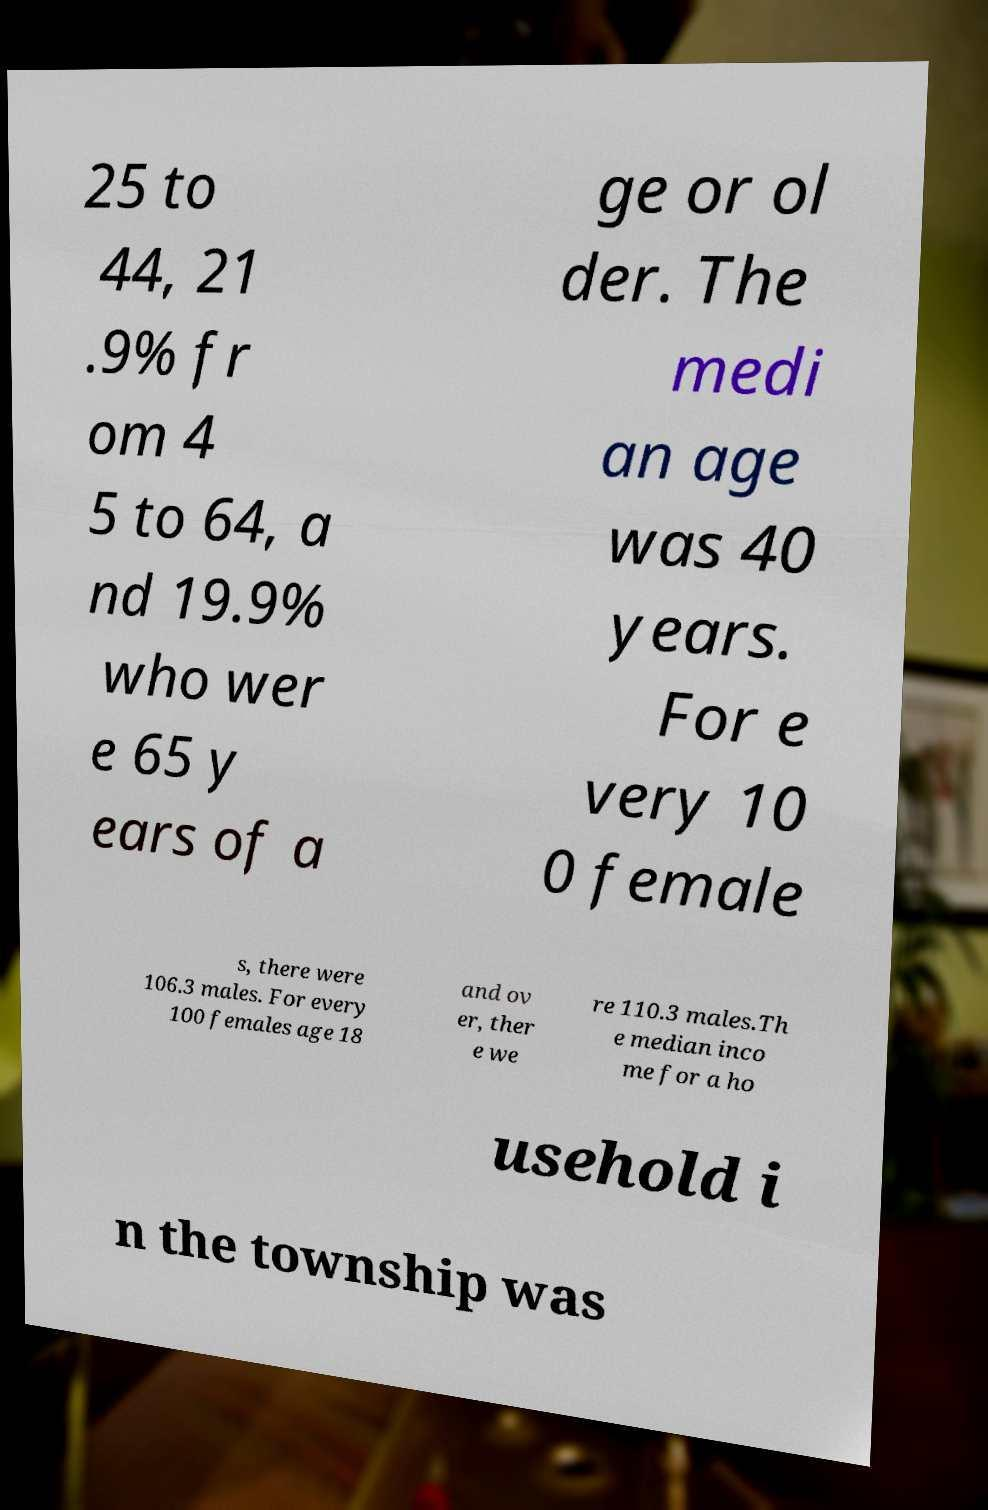Could you assist in decoding the text presented in this image and type it out clearly? 25 to 44, 21 .9% fr om 4 5 to 64, a nd 19.9% who wer e 65 y ears of a ge or ol der. The medi an age was 40 years. For e very 10 0 female s, there were 106.3 males. For every 100 females age 18 and ov er, ther e we re 110.3 males.Th e median inco me for a ho usehold i n the township was 